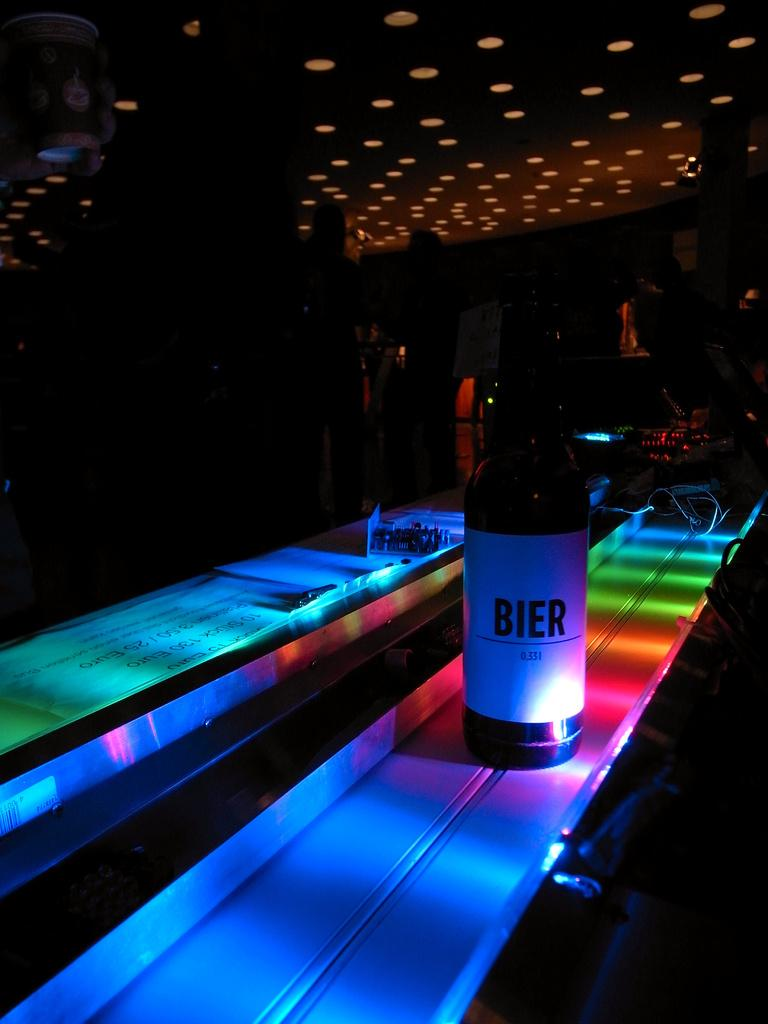<image>
Describe the image concisely. Bottle with a white label that says BIER inside of a dark room. 